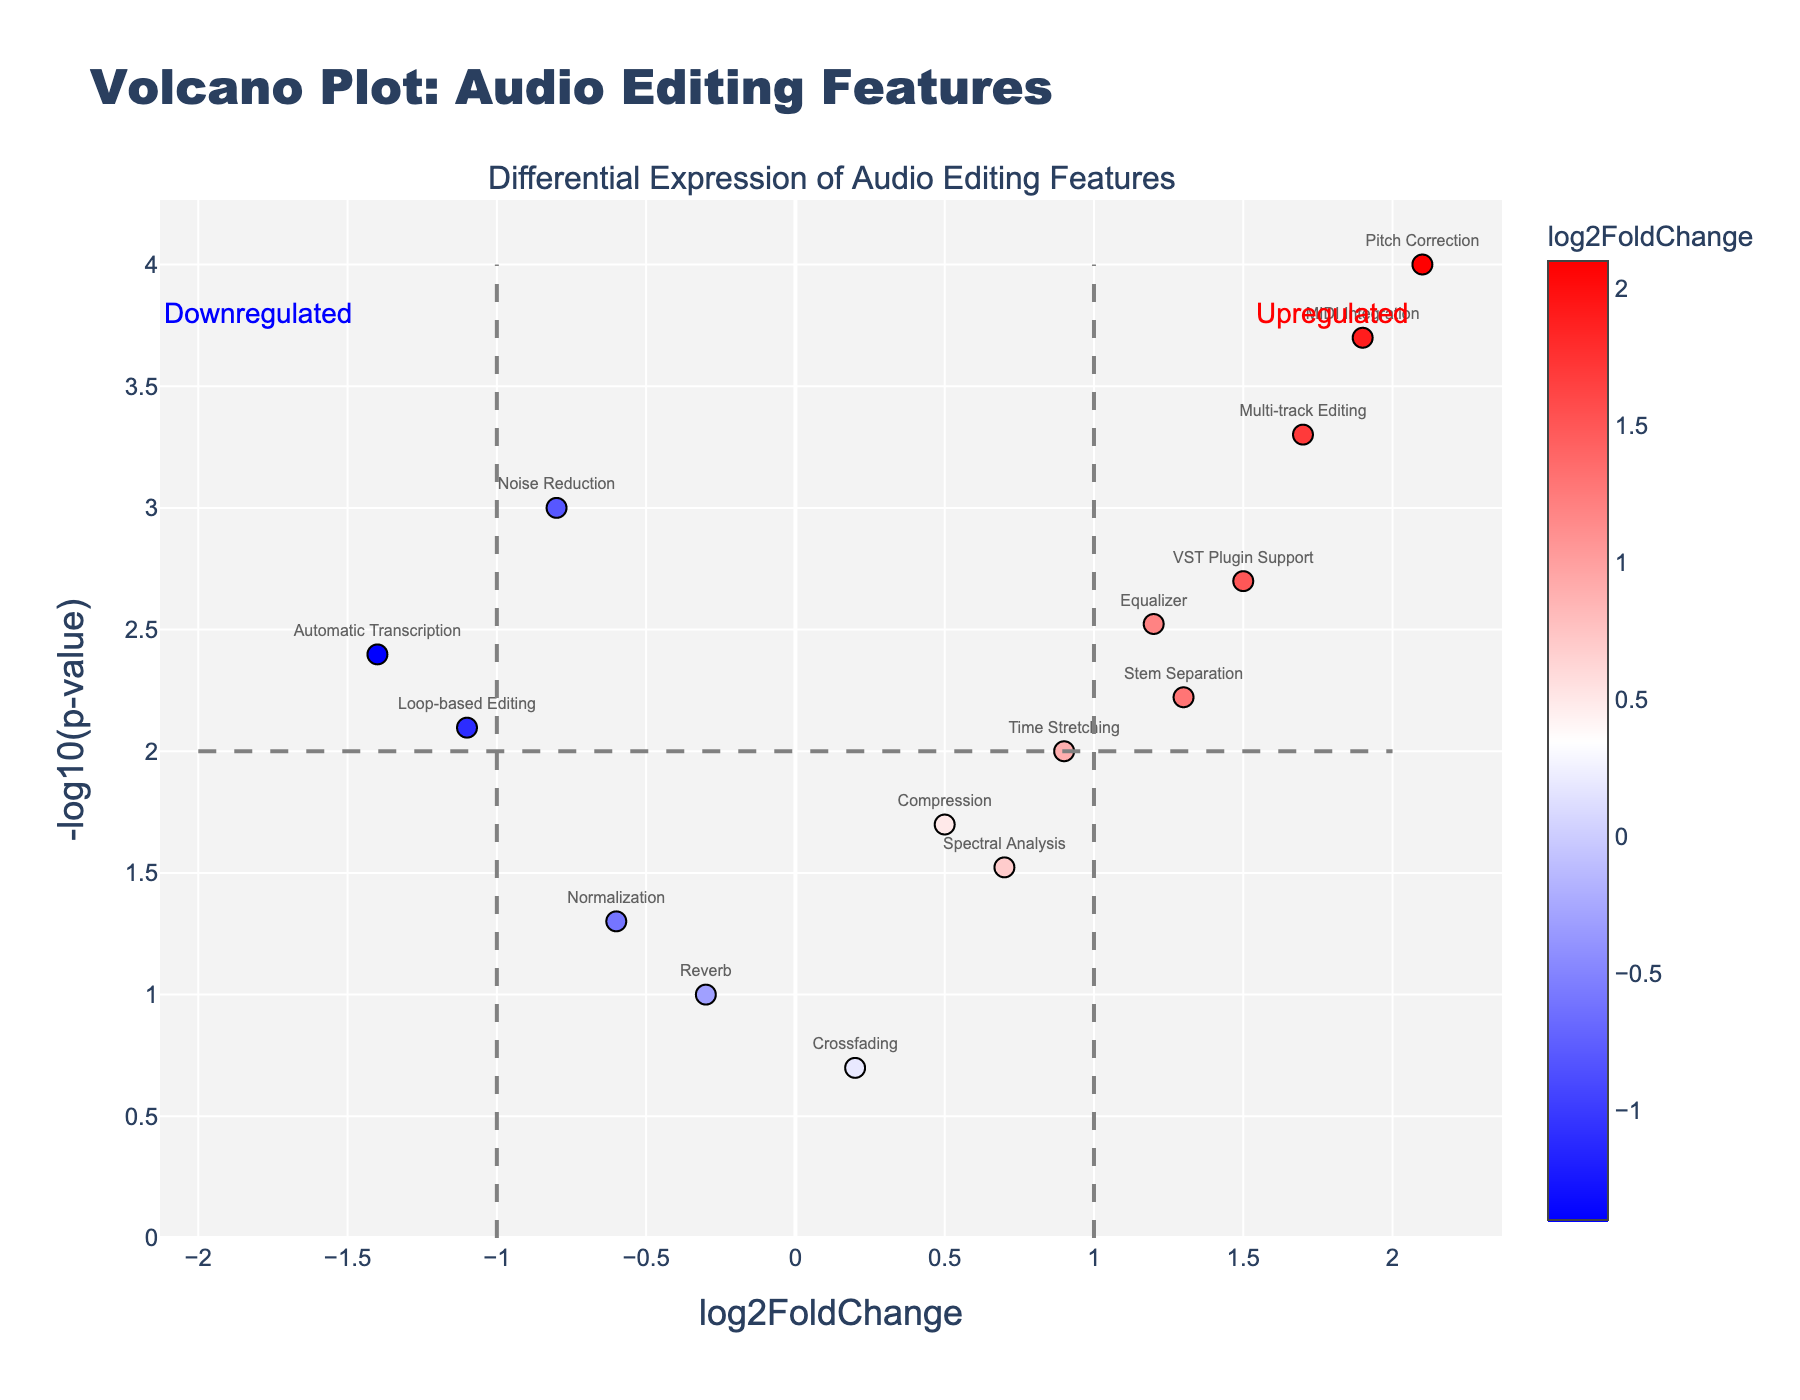What is the title of the plot? The title is displayed at the top of the plot. It states "Volcano Plot: Audio Editing Features".
Answer: Volcano Plot: Audio Editing Features Which feature has the highest log2FoldChange? By looking at the x-axis, which represents log2FoldChange, the point farthest to the right is "Pitch Correction" with a log2FoldChange of 2.1.
Answer: Pitch Correction Which feature has the lowest p-value? The feature with lowest p-value can be found by looking at the highest value on the y-axis, which represents -log10(p-value). "Pitch Correction" has the highest point indicating the lowest p-value of 0.0001.
Answer: Pitch Correction How many features have a log2FoldChange greater than 1? By counting the number of data points to the right of log2FoldChange = 1 on the x-axis, we have "Equalizer", "Multi-track Editing", "VST Plugin Support", "MIDI Integration", and "Stem Separation". There are 5 such features.
Answer: 5 Are there any features with log2FoldChange less than -1? By checking the x-axis for values less than -1, the features "Loop-based Editing" and "Automatic Transcription" fall here, making a total of 2.
Answer: 2 Which features are downregulated? Downregulated features are those with log2FoldChange less than 0. These can be identified as the points on the left side of the y-axis. They include "Noise Reduction", "Reverb", "Normalization", "Loop-based Editing", "Automatic Transcription".
Answer: Noise Reduction, Reverb, Normalization, Loop-based Editing, Automatic Transcription Which upregulated feature has the smallest log2FoldChange? By checking for the smallest positive log2FoldChange value, "Compression" with a log2FoldChange of 0.5 is the feature with the smallest log2FoldChange.
Answer: Compression How many features have a p-value less than 0.01? By looking at the points above the horizontal line at the value corresponding to -log10(0.01) which is 2, we count 6 features: "Noise Reduction", "Equalizer", "Pitch Correction", "Multi-track Editing", "VST Plugin Support", and "MIDI Integration".
Answer: 6 What does the gray dashed vertical line at x = 1 represent? The gray dashed line at x = 1 marks the threshold for upregulated features with a log2FoldChange greater than 1.
Answer: Threshold for upregulated features Is "Automatic Transcription" upregulated or downregulated and by how much? "Automatic Transcription" is downregulated as it has a negative log2FoldChange value of -1.4, indicated by its position on the left part of the plot.
Answer: Downregulated by 1.4 